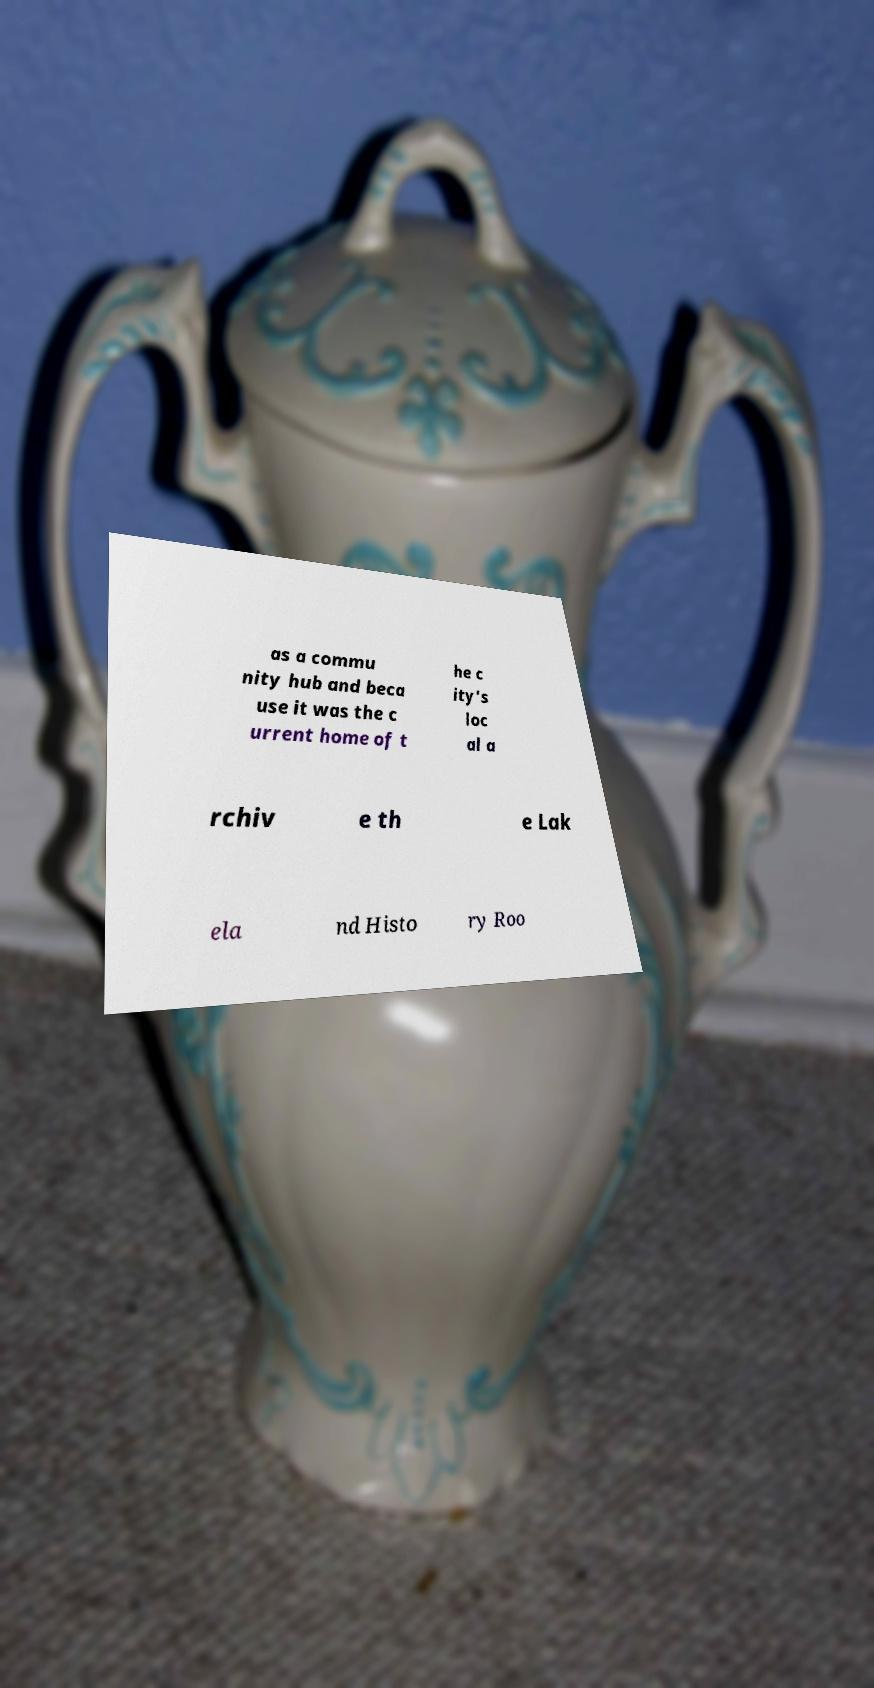Please identify and transcribe the text found in this image. as a commu nity hub and beca use it was the c urrent home of t he c ity's loc al a rchiv e th e Lak ela nd Histo ry Roo 